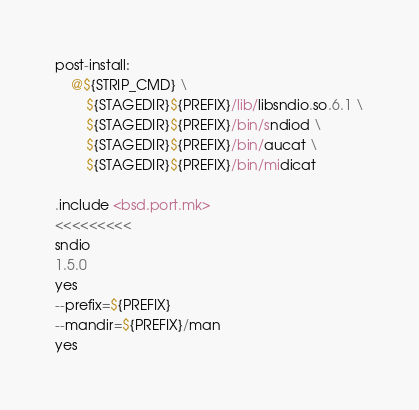Convert code to text. <code><loc_0><loc_0><loc_500><loc_500><_Perl_>
post-install:
	@${STRIP_CMD} \
		${STAGEDIR}${PREFIX}/lib/libsndio.so.6.1 \
		${STAGEDIR}${PREFIX}/bin/sndiod \
		${STAGEDIR}${PREFIX}/bin/aucat \
		${STAGEDIR}${PREFIX}/bin/midicat

.include <bsd.port.mk>
<<<<<<<<<
sndio
1.5.0
yes
--prefix=${PREFIX}
--mandir=${PREFIX}/man
yes
</code> 